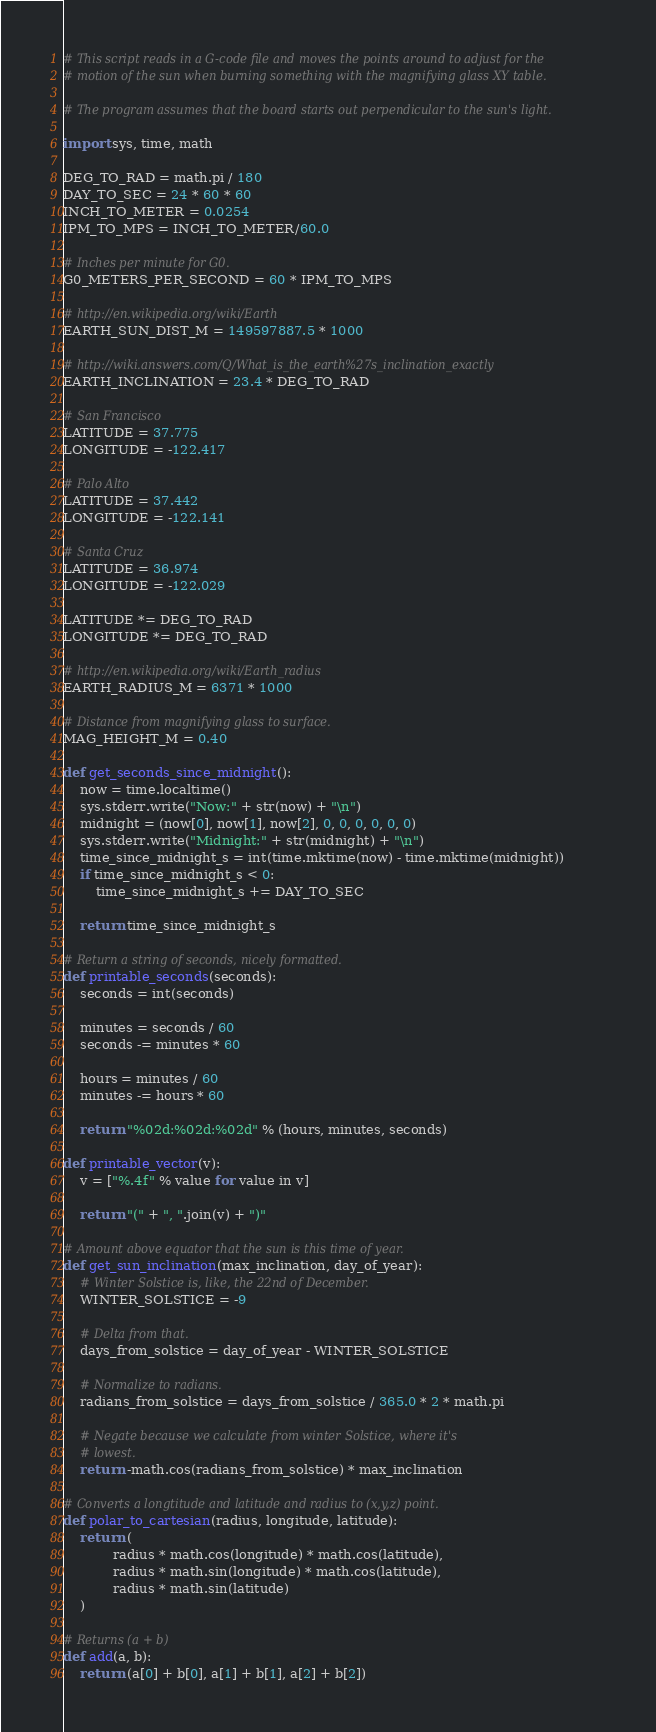Convert code to text. <code><loc_0><loc_0><loc_500><loc_500><_Python_># This script reads in a G-code file and moves the points around to adjust for the
# motion of the sun when burning something with the magnifying glass XY table.

# The program assumes that the board starts out perpendicular to the sun's light.

import sys, time, math

DEG_TO_RAD = math.pi / 180
DAY_TO_SEC = 24 * 60 * 60
INCH_TO_METER = 0.0254
IPM_TO_MPS = INCH_TO_METER/60.0

# Inches per minute for G0.
G0_METERS_PER_SECOND = 60 * IPM_TO_MPS

# http://en.wikipedia.org/wiki/Earth
EARTH_SUN_DIST_M = 149597887.5 * 1000

# http://wiki.answers.com/Q/What_is_the_earth%27s_inclination_exactly
EARTH_INCLINATION = 23.4 * DEG_TO_RAD

# San Francisco
LATITUDE = 37.775
LONGITUDE = -122.417

# Palo Alto
LATITUDE = 37.442
LONGITUDE = -122.141

# Santa Cruz
LATITUDE = 36.974
LONGITUDE = -122.029

LATITUDE *= DEG_TO_RAD
LONGITUDE *= DEG_TO_RAD

# http://en.wikipedia.org/wiki/Earth_radius
EARTH_RADIUS_M = 6371 * 1000

# Distance from magnifying glass to surface.
MAG_HEIGHT_M = 0.40

def get_seconds_since_midnight():
    now = time.localtime()
    sys.stderr.write("Now:" + str(now) + "\n")
    midnight = (now[0], now[1], now[2], 0, 0, 0, 0, 0, 0)
    sys.stderr.write("Midnight:" + str(midnight) + "\n")
    time_since_midnight_s = int(time.mktime(now) - time.mktime(midnight))
    if time_since_midnight_s < 0:
        time_since_midnight_s += DAY_TO_SEC

    return time_since_midnight_s

# Return a string of seconds, nicely formatted.
def printable_seconds(seconds):
    seconds = int(seconds)

    minutes = seconds / 60
    seconds -= minutes * 60

    hours = minutes / 60
    minutes -= hours * 60

    return "%02d:%02d:%02d" % (hours, minutes, seconds)

def printable_vector(v):
    v = ["%.4f" % value for value in v]

    return "(" + ", ".join(v) + ")"

# Amount above equator that the sun is this time of year.
def get_sun_inclination(max_inclination, day_of_year):
    # Winter Solstice is, like, the 22nd of December.
    WINTER_SOLSTICE = -9

    # Delta from that.
    days_from_solstice = day_of_year - WINTER_SOLSTICE

    # Normalize to radians.
    radians_from_solstice = days_from_solstice / 365.0 * 2 * math.pi

    # Negate because we calculate from winter Solstice, where it's
    # lowest.
    return -math.cos(radians_from_solstice) * max_inclination

# Converts a longtitude and latitude and radius to (x,y,z) point.
def polar_to_cartesian(radius, longitude, latitude):
    return (
            radius * math.cos(longitude) * math.cos(latitude),
            radius * math.sin(longitude) * math.cos(latitude),
            radius * math.sin(latitude)
    )

# Returns (a + b)
def add(a, b):
    return (a[0] + b[0], a[1] + b[1], a[2] + b[2])
</code> 